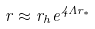<formula> <loc_0><loc_0><loc_500><loc_500>r \approx r _ { h } e ^ { 4 \Lambda r _ { * } }</formula> 